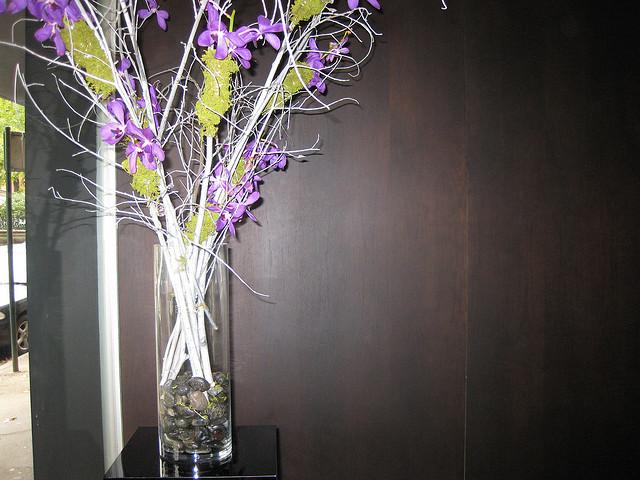How many kinds of flower are in the vase?
Short answer required. 2. Are the flowers artificial?
Quick response, please. Yes. Are these plants real?
Keep it brief. No. Are these vases colorful?
Answer briefly. No. What color are the petals?
Concise answer only. Purple. Is this indoors or outdoors?
Write a very short answer. Indoors. What color is the wall?
Give a very brief answer. Brown. Are the flowers real?
Be succinct. No. Is the vase a cylinder?
Be succinct. Yes. 